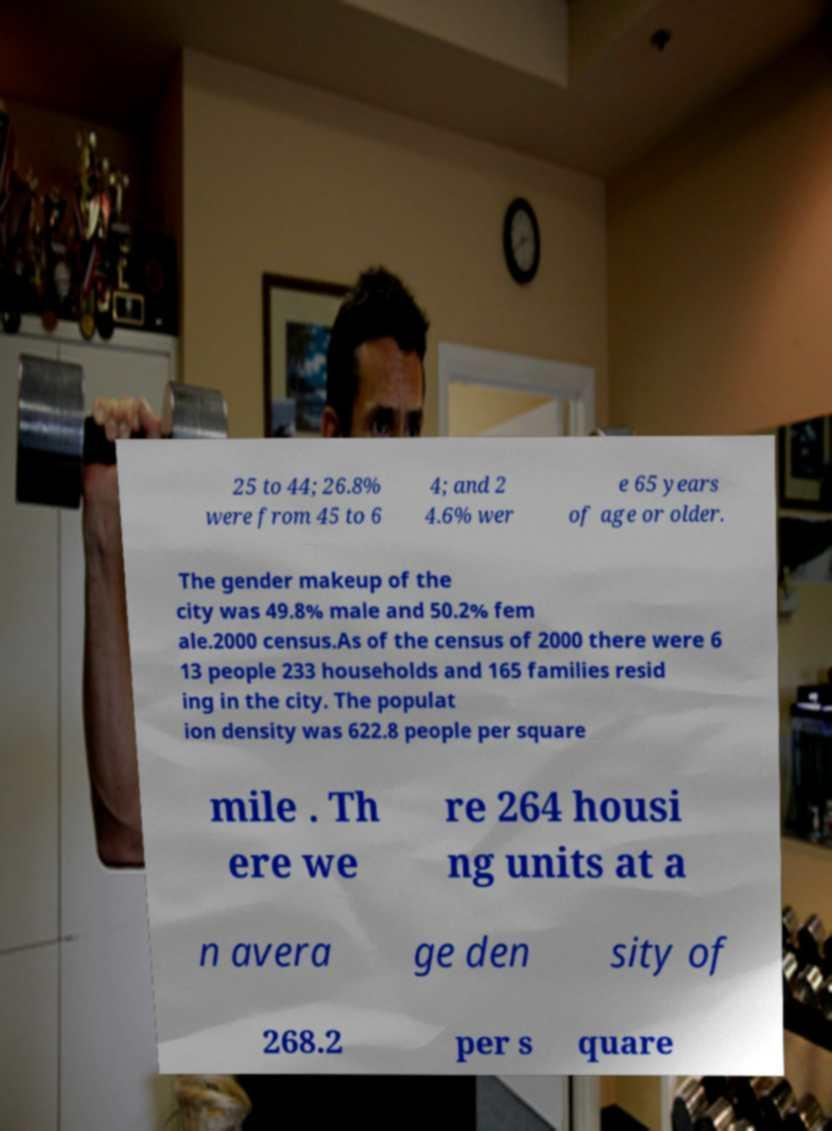Can you accurately transcribe the text from the provided image for me? 25 to 44; 26.8% were from 45 to 6 4; and 2 4.6% wer e 65 years of age or older. The gender makeup of the city was 49.8% male and 50.2% fem ale.2000 census.As of the census of 2000 there were 6 13 people 233 households and 165 families resid ing in the city. The populat ion density was 622.8 people per square mile . Th ere we re 264 housi ng units at a n avera ge den sity of 268.2 per s quare 